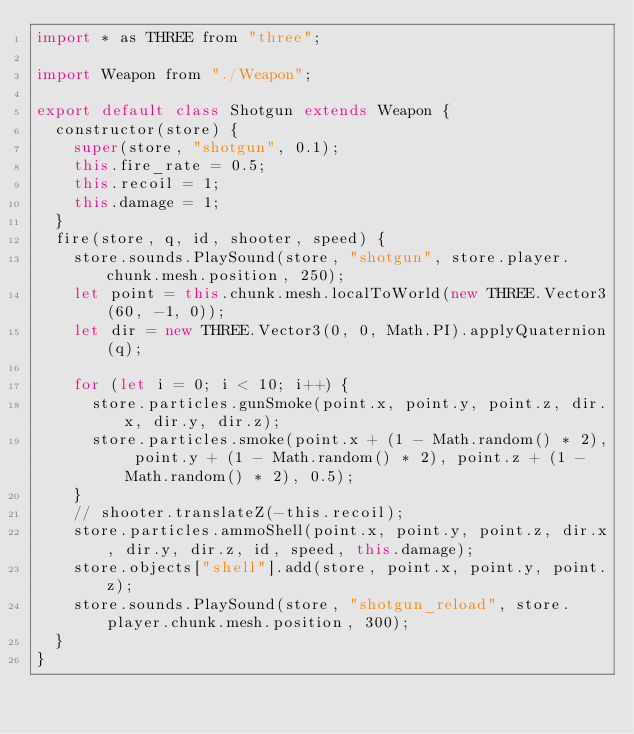Convert code to text. <code><loc_0><loc_0><loc_500><loc_500><_JavaScript_>import * as THREE from "three";

import Weapon from "./Weapon";

export default class Shotgun extends Weapon {
  constructor(store) {
    super(store, "shotgun", 0.1);
    this.fire_rate = 0.5;
    this.recoil = 1;
    this.damage = 1;
  }
  fire(store, q, id, shooter, speed) {
    store.sounds.PlaySound(store, "shotgun", store.player.chunk.mesh.position, 250);
    let point = this.chunk.mesh.localToWorld(new THREE.Vector3(60, -1, 0));
    let dir = new THREE.Vector3(0, 0, Math.PI).applyQuaternion(q);

    for (let i = 0; i < 10; i++) {
      store.particles.gunSmoke(point.x, point.y, point.z, dir.x, dir.y, dir.z);
      store.particles.smoke(point.x + (1 - Math.random() * 2), point.y + (1 - Math.random() * 2), point.z + (1 - Math.random() * 2), 0.5);
    }
    // shooter.translateZ(-this.recoil);
    store.particles.ammoShell(point.x, point.y, point.z, dir.x, dir.y, dir.z, id, speed, this.damage);
    store.objects["shell"].add(store, point.x, point.y, point.z);
    store.sounds.PlaySound(store, "shotgun_reload", store.player.chunk.mesh.position, 300);
  }
}
</code> 